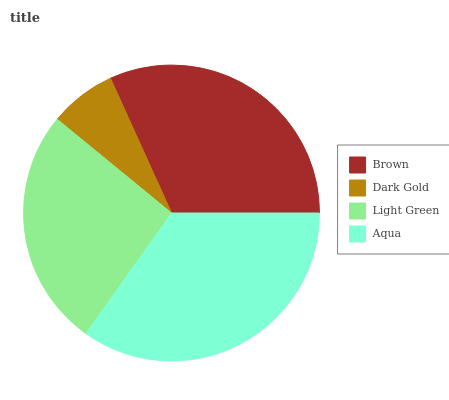Is Dark Gold the minimum?
Answer yes or no. Yes. Is Aqua the maximum?
Answer yes or no. Yes. Is Light Green the minimum?
Answer yes or no. No. Is Light Green the maximum?
Answer yes or no. No. Is Light Green greater than Dark Gold?
Answer yes or no. Yes. Is Dark Gold less than Light Green?
Answer yes or no. Yes. Is Dark Gold greater than Light Green?
Answer yes or no. No. Is Light Green less than Dark Gold?
Answer yes or no. No. Is Brown the high median?
Answer yes or no. Yes. Is Light Green the low median?
Answer yes or no. Yes. Is Dark Gold the high median?
Answer yes or no. No. Is Brown the low median?
Answer yes or no. No. 